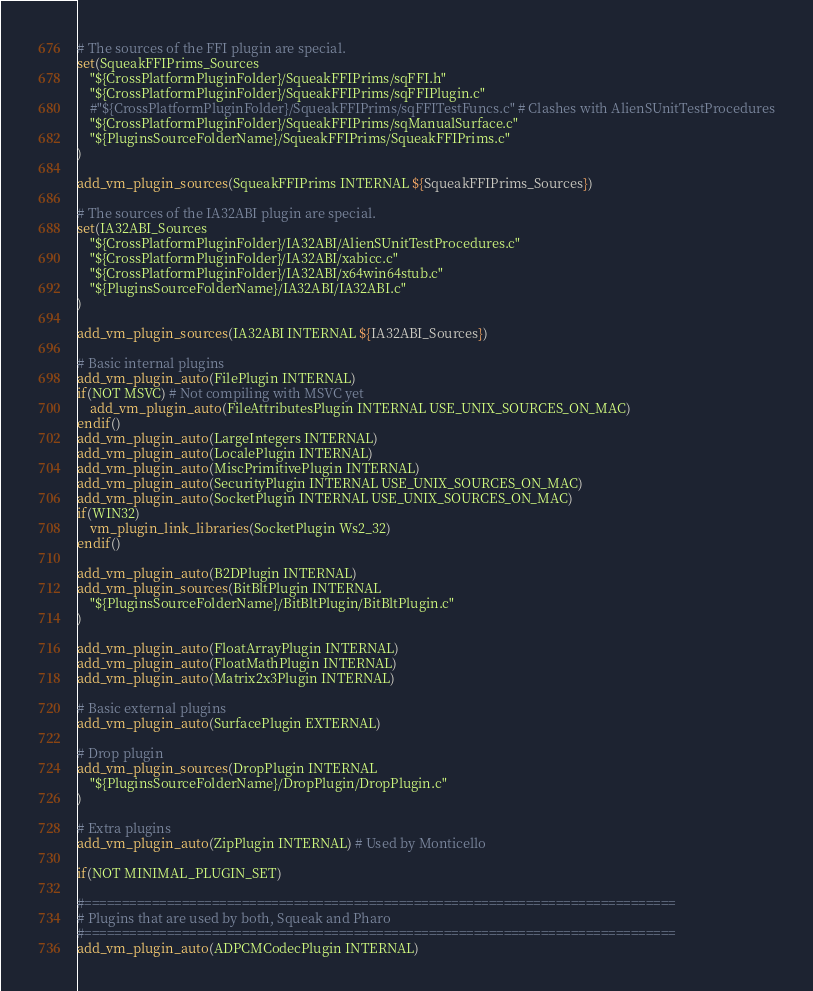Convert code to text. <code><loc_0><loc_0><loc_500><loc_500><_CMake_># The sources of the FFI plugin are special.
set(SqueakFFIPrims_Sources
    "${CrossPlatformPluginFolder}/SqueakFFIPrims/sqFFI.h"
    "${CrossPlatformPluginFolder}/SqueakFFIPrims/sqFFIPlugin.c"
    #"${CrossPlatformPluginFolder}/SqueakFFIPrims/sqFFITestFuncs.c" # Clashes with AlienSUnitTestProcedures
    "${CrossPlatformPluginFolder}/SqueakFFIPrims/sqManualSurface.c"
    "${PluginsSourceFolderName}/SqueakFFIPrims/SqueakFFIPrims.c"
)

add_vm_plugin_sources(SqueakFFIPrims INTERNAL ${SqueakFFIPrims_Sources})

# The sources of the IA32ABI plugin are special.
set(IA32ABI_Sources
    "${CrossPlatformPluginFolder}/IA32ABI/AlienSUnitTestProcedures.c"
    "${CrossPlatformPluginFolder}/IA32ABI/xabicc.c"
    "${CrossPlatformPluginFolder}/IA32ABI/x64win64stub.c"
    "${PluginsSourceFolderName}/IA32ABI/IA32ABI.c"
)

add_vm_plugin_sources(IA32ABI INTERNAL ${IA32ABI_Sources})

# Basic internal plugins
add_vm_plugin_auto(FilePlugin INTERNAL)
if(NOT MSVC) # Not compiling with MSVC yet
    add_vm_plugin_auto(FileAttributesPlugin INTERNAL USE_UNIX_SOURCES_ON_MAC)
endif()
add_vm_plugin_auto(LargeIntegers INTERNAL)
add_vm_plugin_auto(LocalePlugin INTERNAL)
add_vm_plugin_auto(MiscPrimitivePlugin INTERNAL)
add_vm_plugin_auto(SecurityPlugin INTERNAL USE_UNIX_SOURCES_ON_MAC)
add_vm_plugin_auto(SocketPlugin INTERNAL USE_UNIX_SOURCES_ON_MAC)
if(WIN32)
    vm_plugin_link_libraries(SocketPlugin Ws2_32)
endif()

add_vm_plugin_auto(B2DPlugin INTERNAL)
add_vm_plugin_sources(BitBltPlugin INTERNAL
    "${PluginsSourceFolderName}/BitBltPlugin/BitBltPlugin.c"
)

add_vm_plugin_auto(FloatArrayPlugin INTERNAL)
add_vm_plugin_auto(FloatMathPlugin INTERNAL)
add_vm_plugin_auto(Matrix2x3Plugin INTERNAL)

# Basic external plugins
add_vm_plugin_auto(SurfacePlugin EXTERNAL)

# Drop plugin
add_vm_plugin_sources(DropPlugin INTERNAL
    "${PluginsSourceFolderName}/DropPlugin/DropPlugin.c"
)

# Extra plugins
add_vm_plugin_auto(ZipPlugin INTERNAL) # Used by Monticello

if(NOT MINIMAL_PLUGIN_SET)

#===============================================================================
# Plugins that are used by both, Squeak and Pharo
#===============================================================================
add_vm_plugin_auto(ADPCMCodecPlugin INTERNAL)</code> 